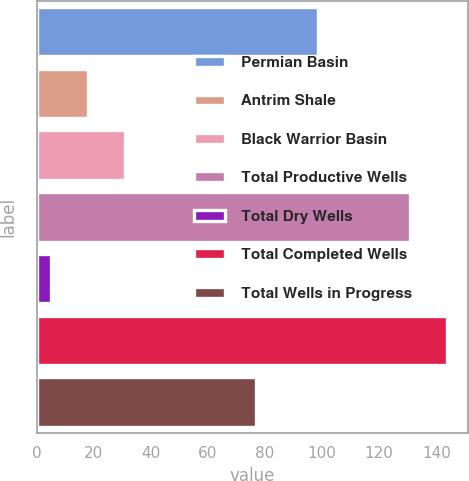Convert chart. <chart><loc_0><loc_0><loc_500><loc_500><bar_chart><fcel>Permian Basin<fcel>Antrim Shale<fcel>Black Warrior Basin<fcel>Total Productive Wells<fcel>Total Dry Wells<fcel>Total Completed Wells<fcel>Total Wells in Progress<nl><fcel>98.5<fcel>18.07<fcel>31.14<fcel>130.7<fcel>5<fcel>143.77<fcel>76.9<nl></chart> 